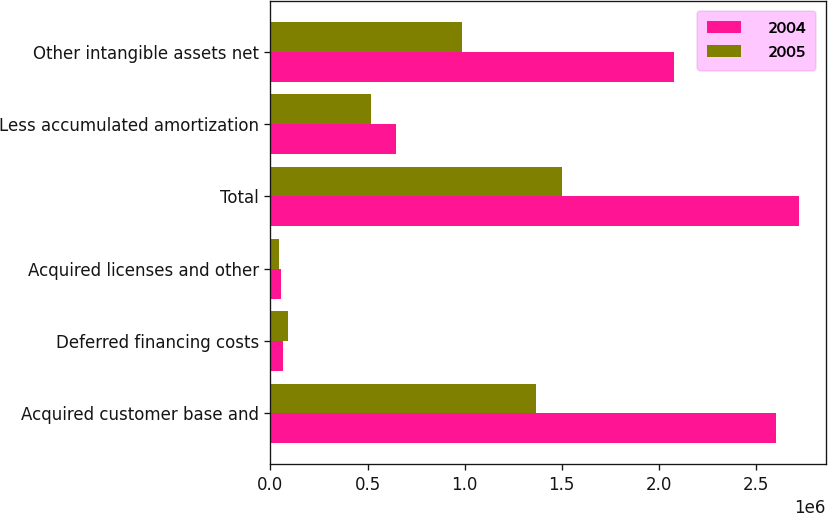Convert chart. <chart><loc_0><loc_0><loc_500><loc_500><stacked_bar_chart><ecel><fcel>Acquired customer base and<fcel>Deferred financing costs<fcel>Acquired licenses and other<fcel>Total<fcel>Less accumulated amortization<fcel>Other intangible assets net<nl><fcel>2004<fcel>2.60655e+06<fcel>65623<fcel>51703<fcel>2.72387e+06<fcel>646560<fcel>2.07731e+06<nl><fcel>2005<fcel>1.36961e+06<fcel>89736<fcel>43404<fcel>1.50275e+06<fcel>517444<fcel>985303<nl></chart> 